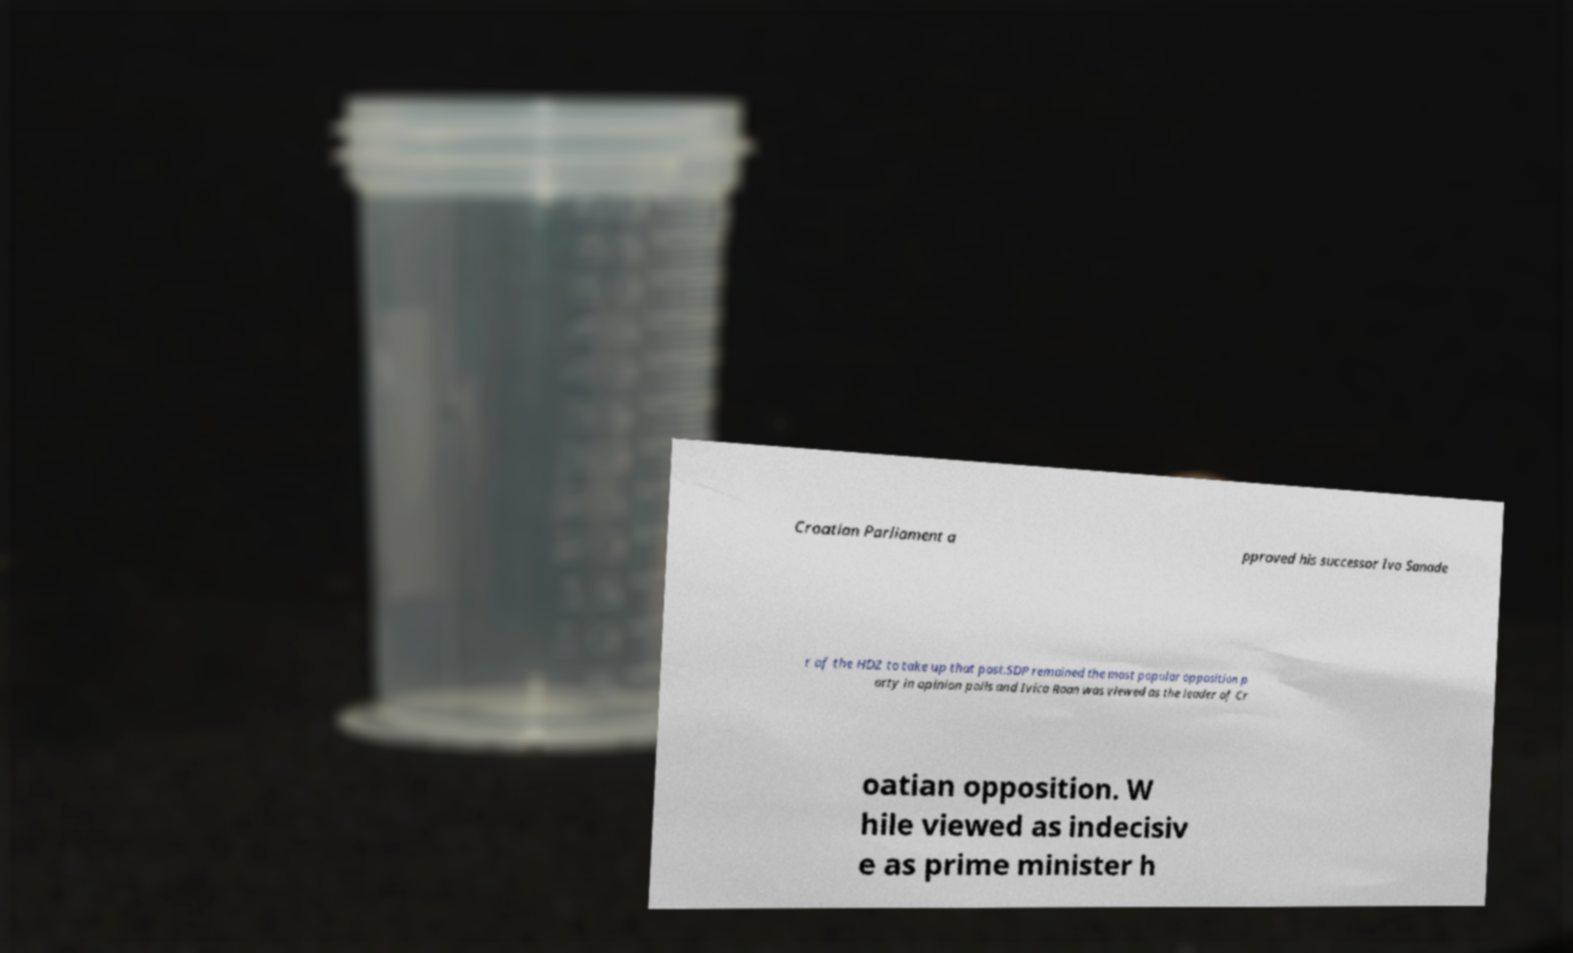There's text embedded in this image that I need extracted. Can you transcribe it verbatim? Croatian Parliament a pproved his successor Ivo Sanade r of the HDZ to take up that post.SDP remained the most popular opposition p arty in opinion polls and Ivica Raan was viewed as the leader of Cr oatian opposition. W hile viewed as indecisiv e as prime minister h 